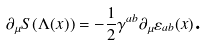<formula> <loc_0><loc_0><loc_500><loc_500>\partial _ { \mu } S ( \Lambda ( x ) ) = - \frac { 1 } { 2 } \gamma ^ { a b } \partial _ { \mu } \varepsilon _ { a b } ( x ) \text {.}</formula> 